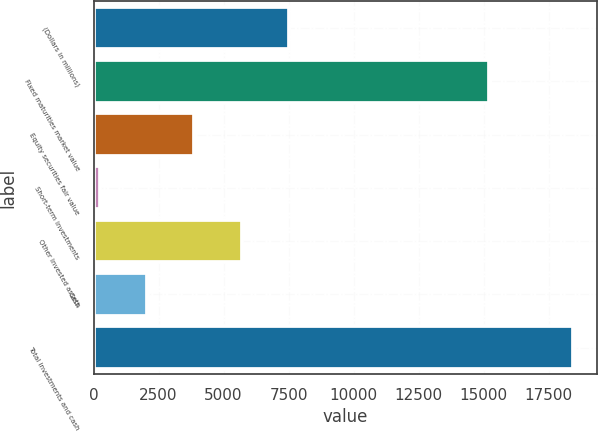Convert chart. <chart><loc_0><loc_0><loc_500><loc_500><bar_chart><fcel>(Dollars in millions)<fcel>Fixed maturities market value<fcel>Equity securities fair value<fcel>Short-term investments<fcel>Other invested assets<fcel>Cash<fcel>Total investments and cash<nl><fcel>7517.84<fcel>15225.3<fcel>3879.42<fcel>241<fcel>5698.63<fcel>2060.21<fcel>18433.1<nl></chart> 